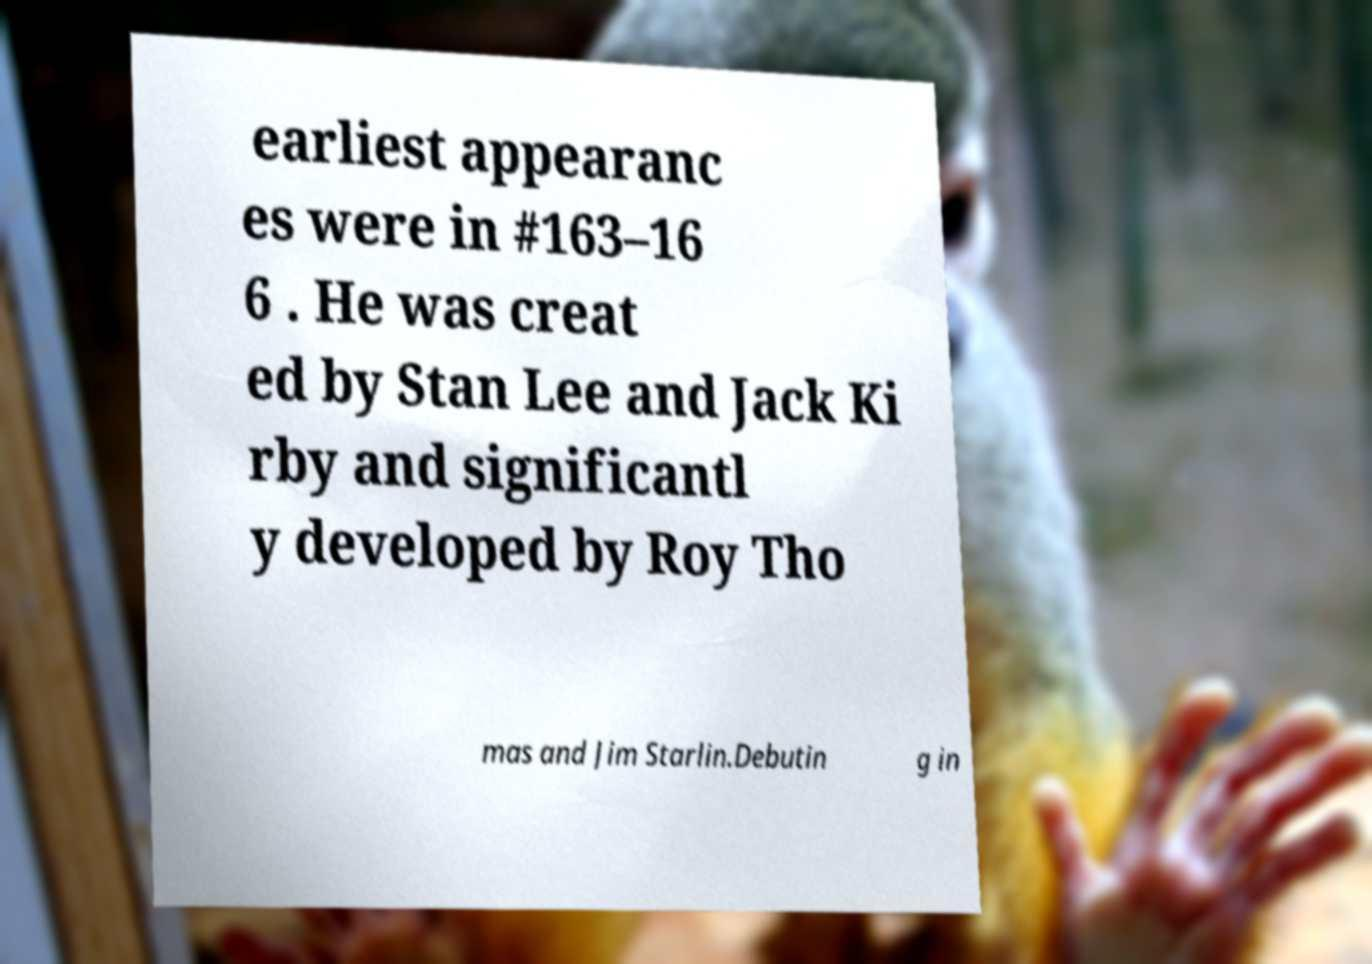What messages or text are displayed in this image? I need them in a readable, typed format. earliest appearanc es were in #163–16 6 . He was creat ed by Stan Lee and Jack Ki rby and significantl y developed by Roy Tho mas and Jim Starlin.Debutin g in 